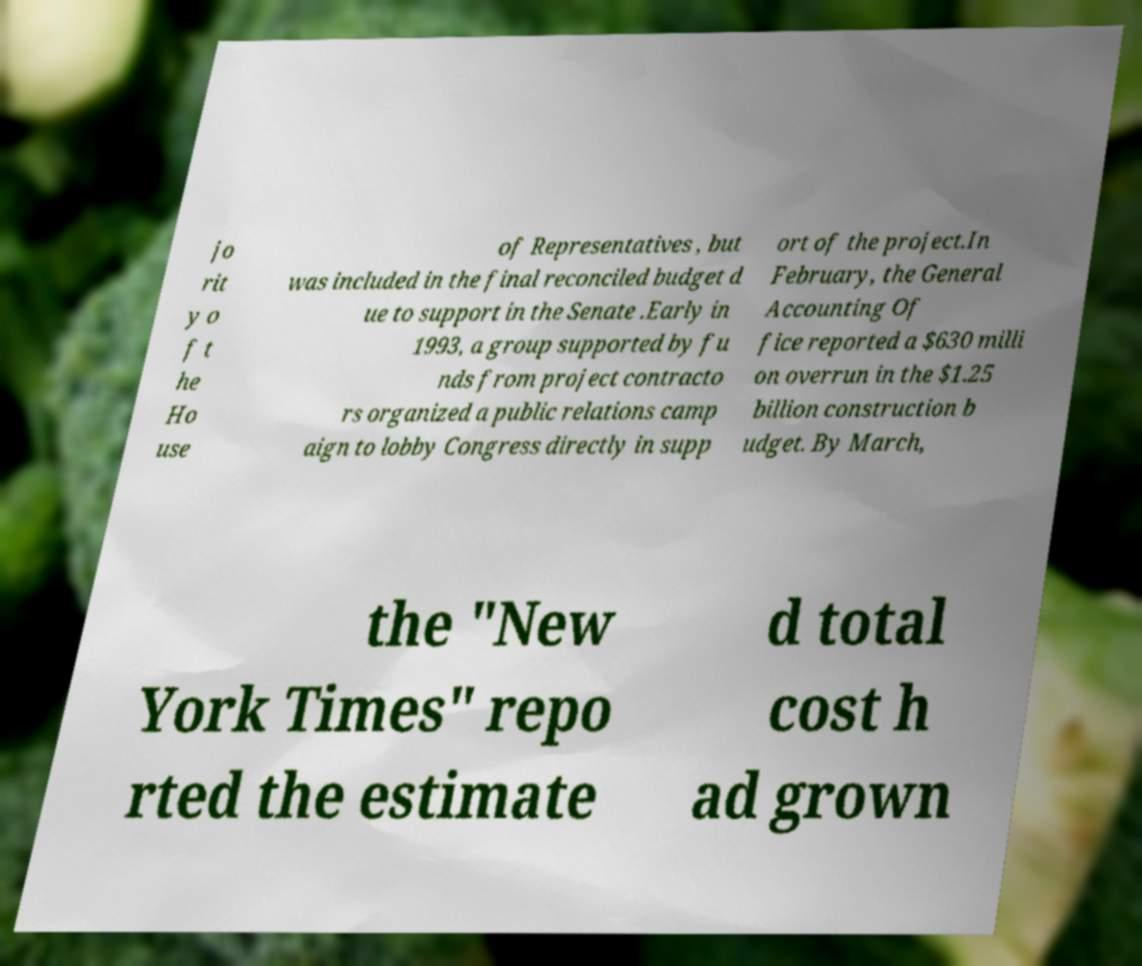Can you read and provide the text displayed in the image?This photo seems to have some interesting text. Can you extract and type it out for me? jo rit y o f t he Ho use of Representatives , but was included in the final reconciled budget d ue to support in the Senate .Early in 1993, a group supported by fu nds from project contracto rs organized a public relations camp aign to lobby Congress directly in supp ort of the project.In February, the General Accounting Of fice reported a $630 milli on overrun in the $1.25 billion construction b udget. By March, the "New York Times" repo rted the estimate d total cost h ad grown 